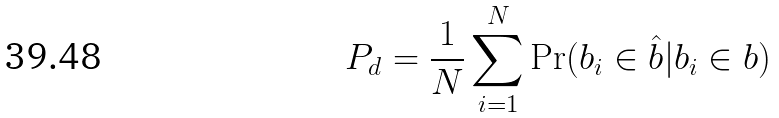Convert formula to latex. <formula><loc_0><loc_0><loc_500><loc_500>P _ { d } = \frac { 1 } { N } \sum _ { i = 1 } ^ { N } \Pr ( b _ { i } \in \hat { b } | b _ { i } \in b )</formula> 